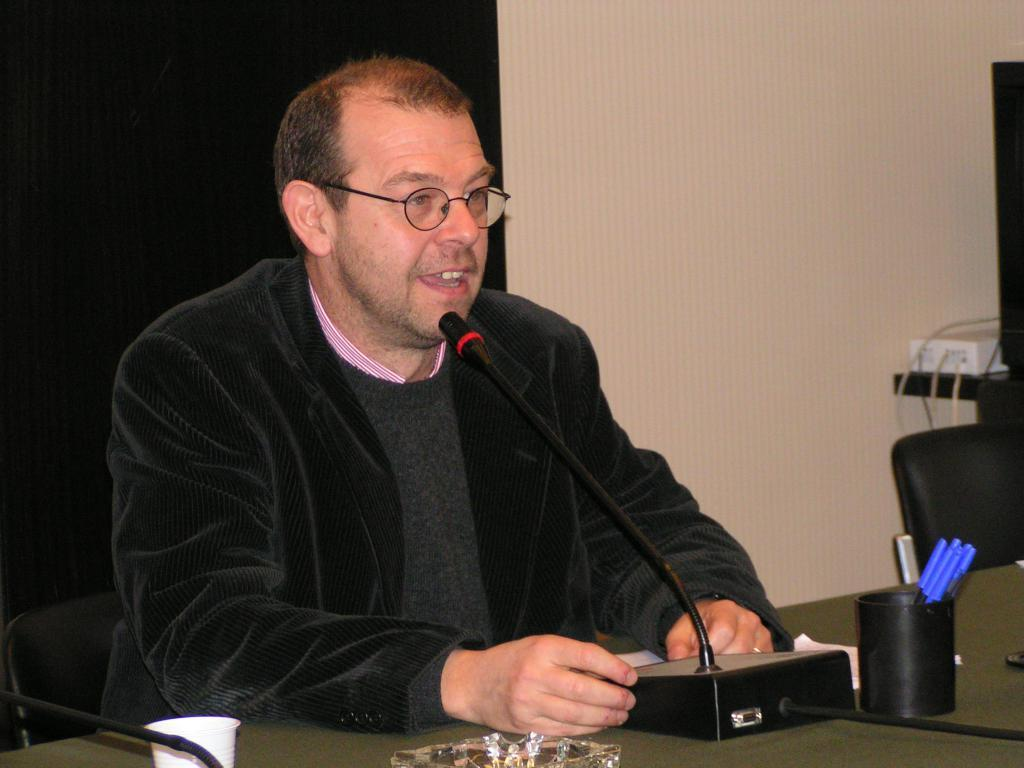What is the man in the image doing? The man is sitting in a chair and speaking on a microphone. Where is the man located in relation to the table? The man is in front of a table. What objects are on the stand in the image? The stand has pens, a cup, an ash tray, and cables connected to a socket. What type of eggnog is being served at the event in the image? There is no mention of eggnog or any event in the image; it simply shows a man sitting in a chair and speaking on a microphone. 